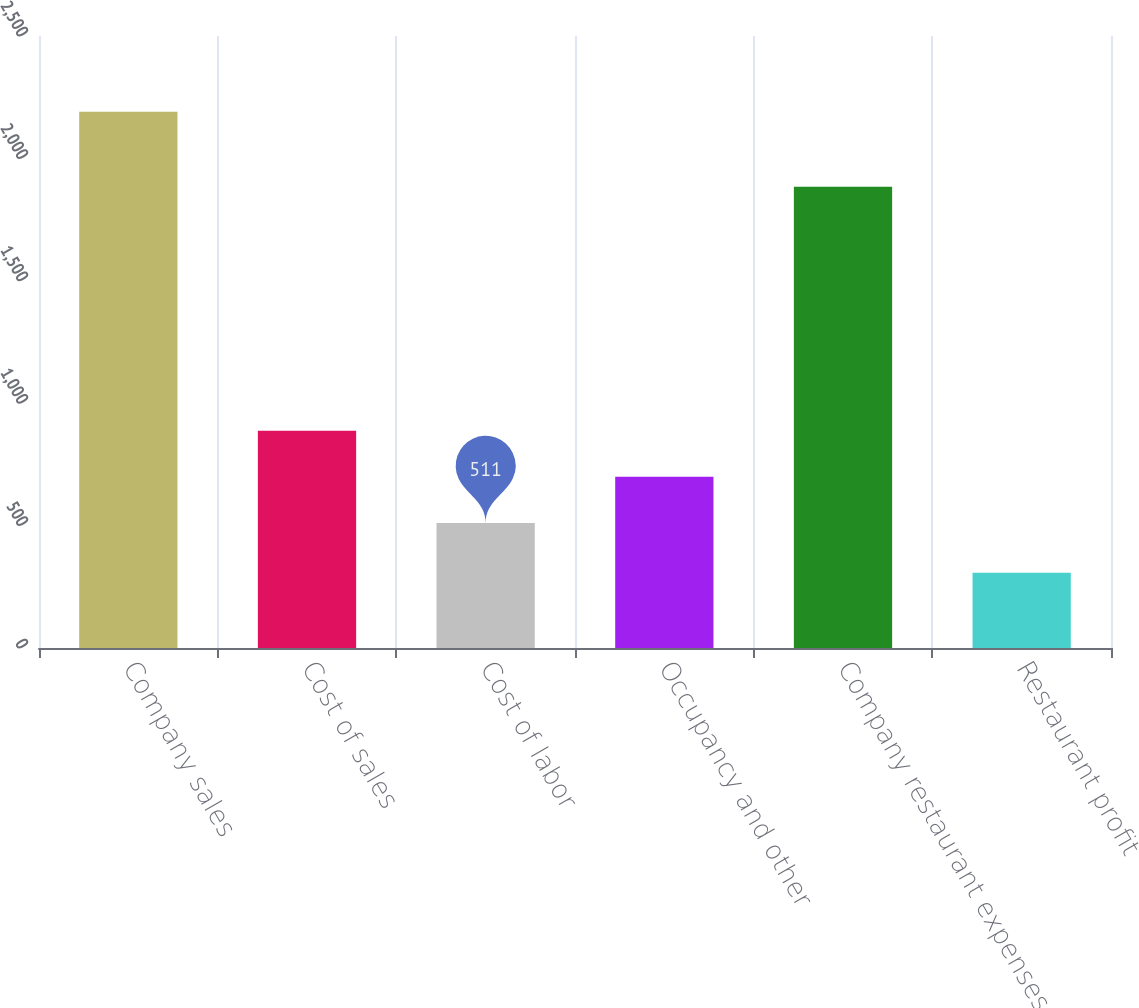Convert chart to OTSL. <chart><loc_0><loc_0><loc_500><loc_500><bar_chart><fcel>Company sales<fcel>Cost of sales<fcel>Cost of labor<fcel>Occupancy and other<fcel>Company restaurant expenses<fcel>Restaurant profit<nl><fcel>2191<fcel>887.8<fcel>511<fcel>699.4<fcel>1884<fcel>307<nl></chart> 